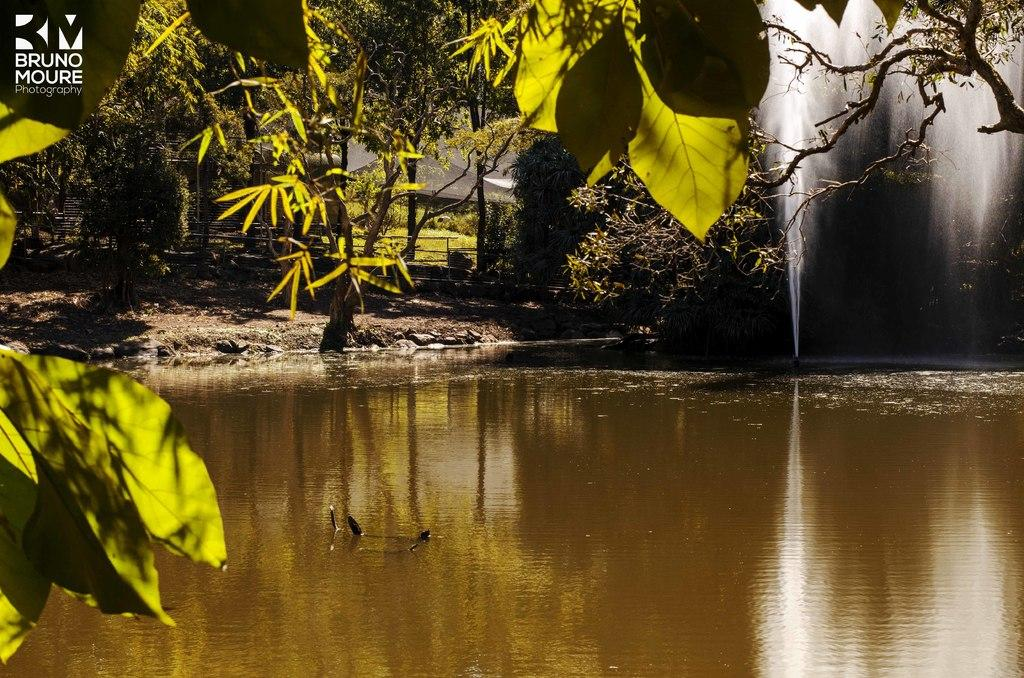Where was the image taken? The image was clicked outside. What can be seen at the bottom of the image? There is water at the bottom of the image. What is visible in the background of the image? There are trees and plants in the background of the image. What is located to the right of the image? There is a fountain to the right of the image. What hobbies are the zebras engaging in at the bottom of the image? There are no zebras present in the image, so it is not possible to answer that question. 